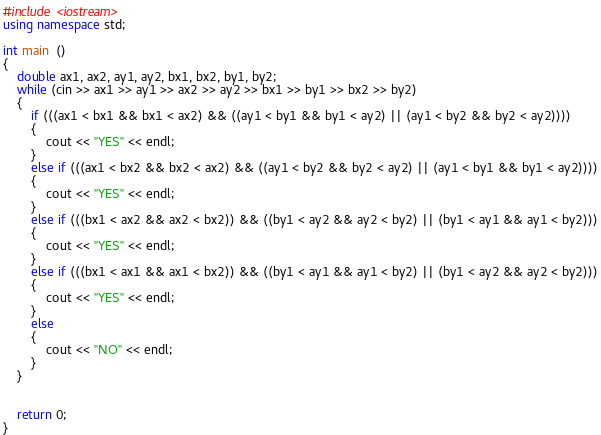Convert code to text. <code><loc_0><loc_0><loc_500><loc_500><_C++_>#include <iostream>
using namespace std;

int main  ()
{
    double ax1, ax2, ay1, ay2, bx1, bx2, by1, by2;
    while (cin >> ax1 >> ay1 >> ax2 >> ay2 >> bx1 >> by1 >> bx2 >> by2)
    {
        if (((ax1 < bx1 && bx1 < ax2) && ((ay1 < by1 && by1 < ay2) || (ay1 < by2 && by2 < ay2))))
        {
            cout << "YES" << endl;
        }
        else if (((ax1 < bx2 && bx2 < ax2) && ((ay1 < by2 && by2 < ay2) || (ay1 < by1 && by1 < ay2))))
        {
            cout << "YES" << endl;
        }
        else if (((bx1 < ax2 && ax2 < bx2)) && ((by1 < ay2 && ay2 < by2) || (by1 < ay1 && ay1 < by2)))
        {
            cout << "YES" << endl;
        }
        else if (((bx1 < ax1 && ax1 < bx2)) && ((by1 < ay1 && ay1 < by2) || (by1 < ay2 && ay2 < by2)))
        {
            cout << "YES" << endl;
        }
        else
        {
            cout << "NO" << endl;
        }
    }


    return 0;
}</code> 